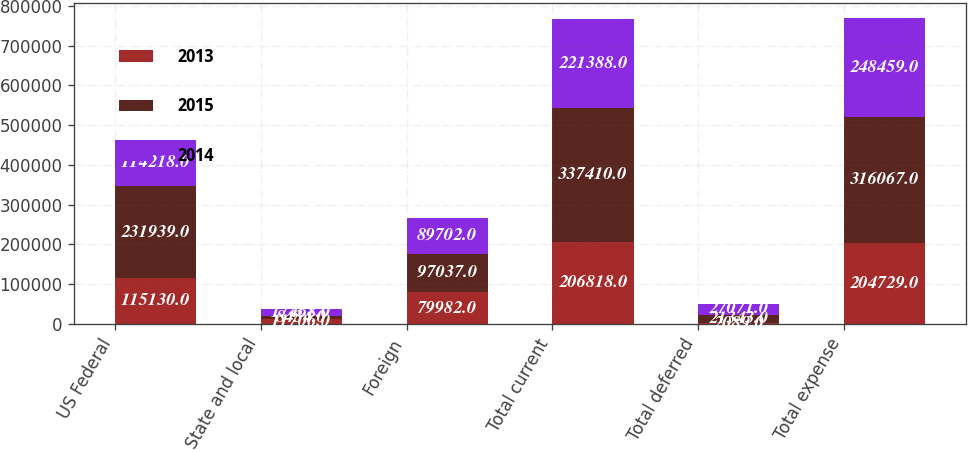Convert chart. <chart><loc_0><loc_0><loc_500><loc_500><stacked_bar_chart><ecel><fcel>US Federal<fcel>State and local<fcel>Foreign<fcel>Total current<fcel>Total deferred<fcel>Total expense<nl><fcel>2013<fcel>115130<fcel>11706<fcel>79982<fcel>206818<fcel>2089<fcel>204729<nl><fcel>2015<fcel>231939<fcel>8434<fcel>97037<fcel>337410<fcel>21343<fcel>316067<nl><fcel>2014<fcel>114218<fcel>17468<fcel>89702<fcel>221388<fcel>27071<fcel>248459<nl></chart> 